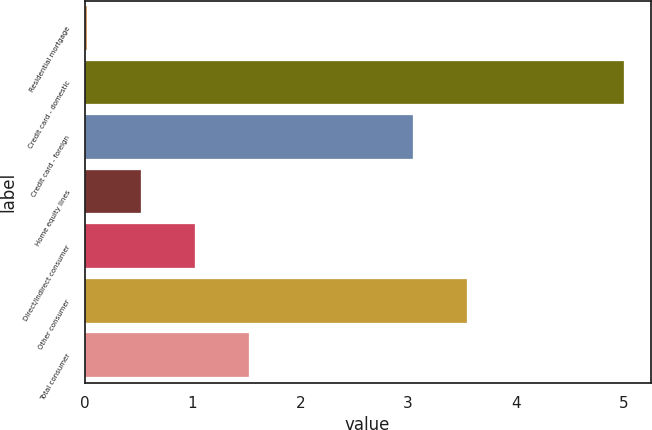Convert chart. <chart><loc_0><loc_0><loc_500><loc_500><bar_chart><fcel>Residential mortgage<fcel>Credit card - domestic<fcel>Credit card - foreign<fcel>Home equity lines<fcel>Direct/Indirect consumer<fcel>Other consumer<fcel>Total consumer<nl><fcel>0.02<fcel>5<fcel>3.05<fcel>0.52<fcel>1.02<fcel>3.55<fcel>1.52<nl></chart> 